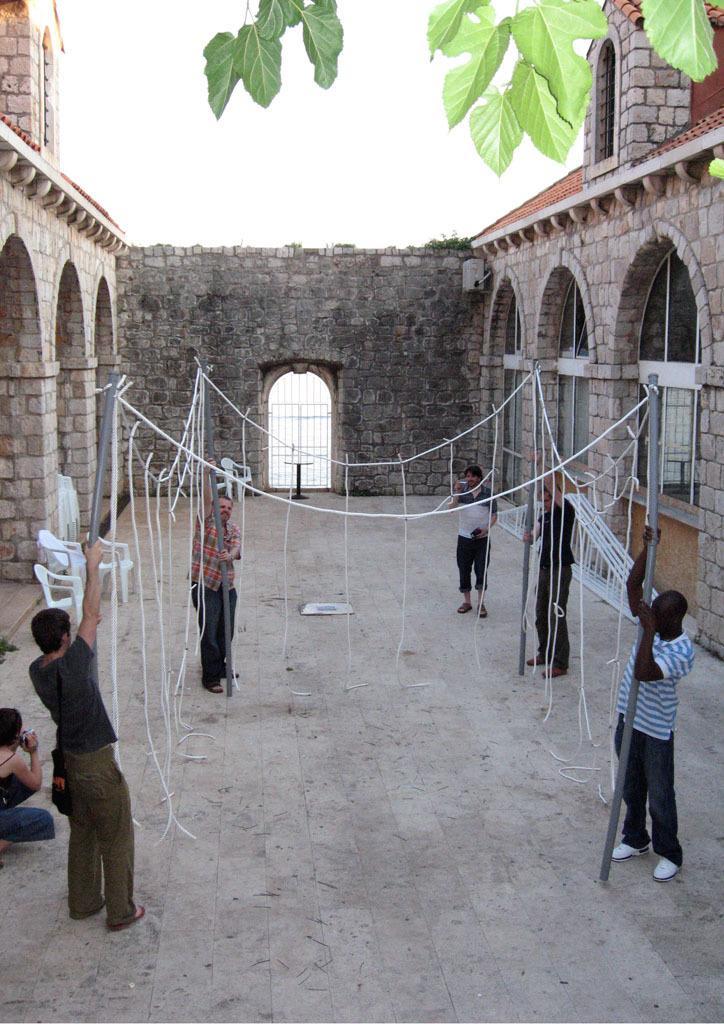In one or two sentences, can you explain what this image depicts? This image is taken from inside the fort. In this image we can see there are a few people standing and holding the poles and some threads are connected to this pole. On the left side of the image we can see there is a girl taking pictures with the camera and there are some chairs. In the background there is a sky. At the top of the image we can see there are some leaves of a tree. 